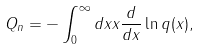Convert formula to latex. <formula><loc_0><loc_0><loc_500><loc_500>Q _ { n } = - \int _ { 0 } ^ { \infty } d x x \frac { d } { d x } \ln q ( x ) ,</formula> 